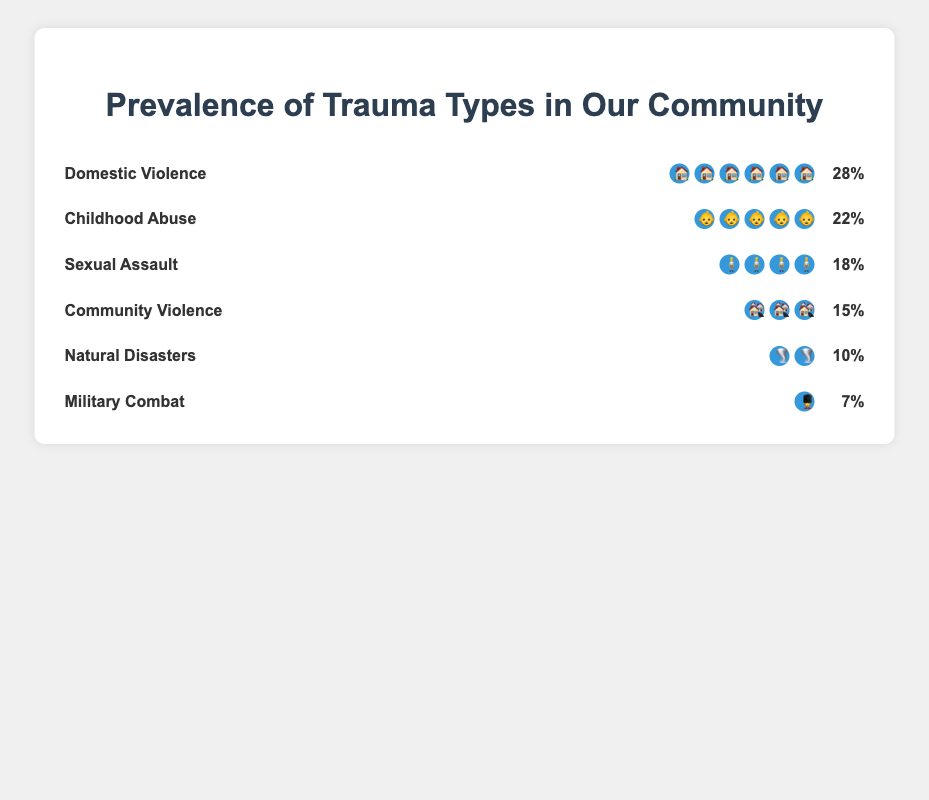What type of trauma has the highest prevalence in the community? The plot shows different types of trauma along with their prevalence. By checking the prevalence percentages, Domestic Violence has the highest, at 28%.
Answer: Domestic Violence Which two trauma types have the closest prevalence? By comparing the prevalence percentages of all trauma types, Community Violence at 15% and Natural Disasters at 10% are the closest, with a difference of 5%.
Answer: Community Violence and Natural Disasters What's the combined prevalence of Sexual Assault and Military Combat? The prevalence of Sexual Assault is 18% and Military Combat is 7%. Adding them together equals 25%.
Answer: 25% What is the difference in prevalence between Childhood Abuse and Community Violence? Childhood Abuse has a prevalence of 22% and Community Violence has 15%. The difference is 22% - 15% = 7%.
Answer: 7% Which type of trauma has the lowest prevalence in the community? The plot shows different types of trauma and their prevalence. Military Combat has the lowest prevalence at 7%.
Answer: Military Combat How many trauma types have a prevalence greater than 20%? By reviewing the prevalence percentages, Domestic Violence (28%) and Childhood Abuse (22%) are greater than 20%. There are two such trauma types.
Answer: 2 List the trauma types in order from the highest to the lowest prevalence. From the plot, the order is as follows: Domestic Violence (28%), Childhood Abuse (22%), Sexual Assault (18%), Community Violence (15%), Natural Disasters (10%), Military Combat (7%).
Answer: Domestic Violence, Childhood Abuse, Sexual Assault, Community Violence, Natural Disasters, Military Combat What is the average prevalence of all the trauma types reported? Adding all the prevalence percentages (28 + 22 + 18 + 15 + 10 + 7) gives a total of 100. There are 6 trauma types, so the average is 100 / 6 = 16.67%.
Answer: 16.67% How does the prevalence of Natural Disasters compare to Sexual Assault? The prevalence of Natural Disasters is 10%, while Sexual Assault is 18%. Natural Disasters have a lower prevalence compared to Sexual Assault.
Answer: Lower What proportion of the reported trauma types have a prevalence under 20%? The trauma types with prevalence under 20% are Community Violence (15%), Natural Disasters (10%), Military Combat (7%), and Sexual Assault (18%). Since 4 out of 6 trauma types meet this criterion, the proportion is 4/6 or approximately 66.7%.
Answer: 66.7% 